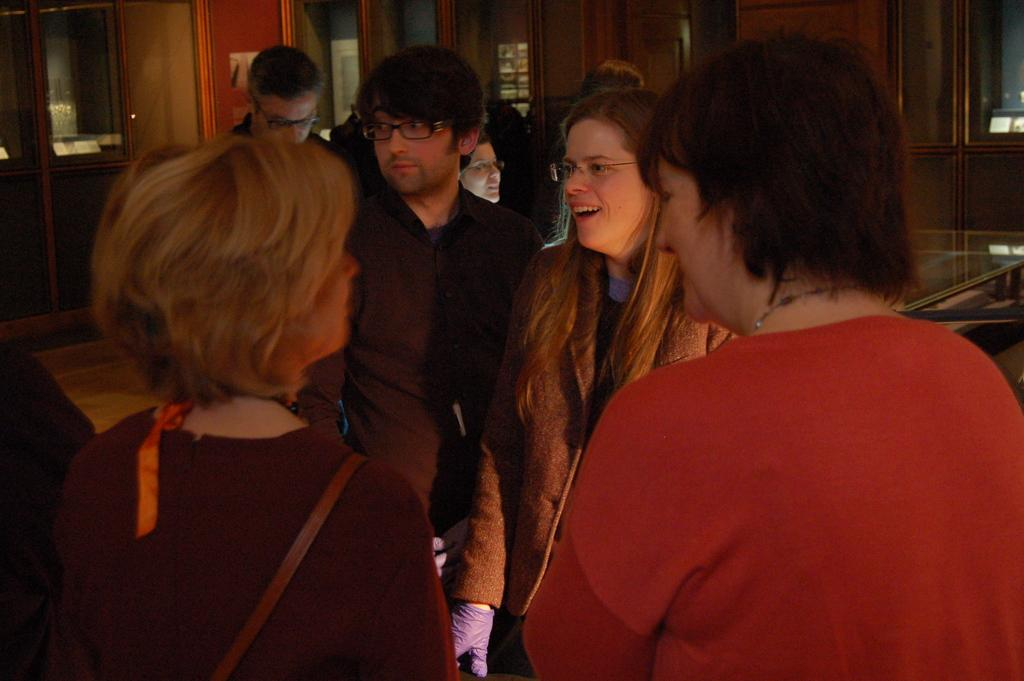How many people are in the group shown in the image? There is a group of people in the image, but the exact number is not specified. What is the color of the shirt worn by one person in the group? One person in the group is wearing a red shirt. What can be seen in the background of the image? There are windows and brown-colored cupboards visible in the background. What type of corn is being harvested by the people in the image? There is no corn visible in the image, nor are the people engaged in any harvesting activities. 